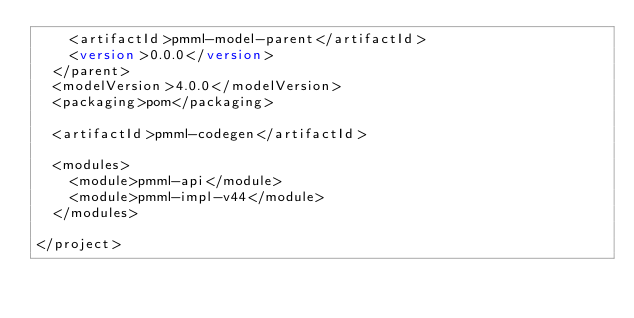Convert code to text. <code><loc_0><loc_0><loc_500><loc_500><_XML_>    <artifactId>pmml-model-parent</artifactId>
    <version>0.0.0</version>
  </parent>
  <modelVersion>4.0.0</modelVersion>
  <packaging>pom</packaging>

  <artifactId>pmml-codegen</artifactId>

  <modules>
    <module>pmml-api</module>
    <module>pmml-impl-v44</module>
  </modules>

</project></code> 